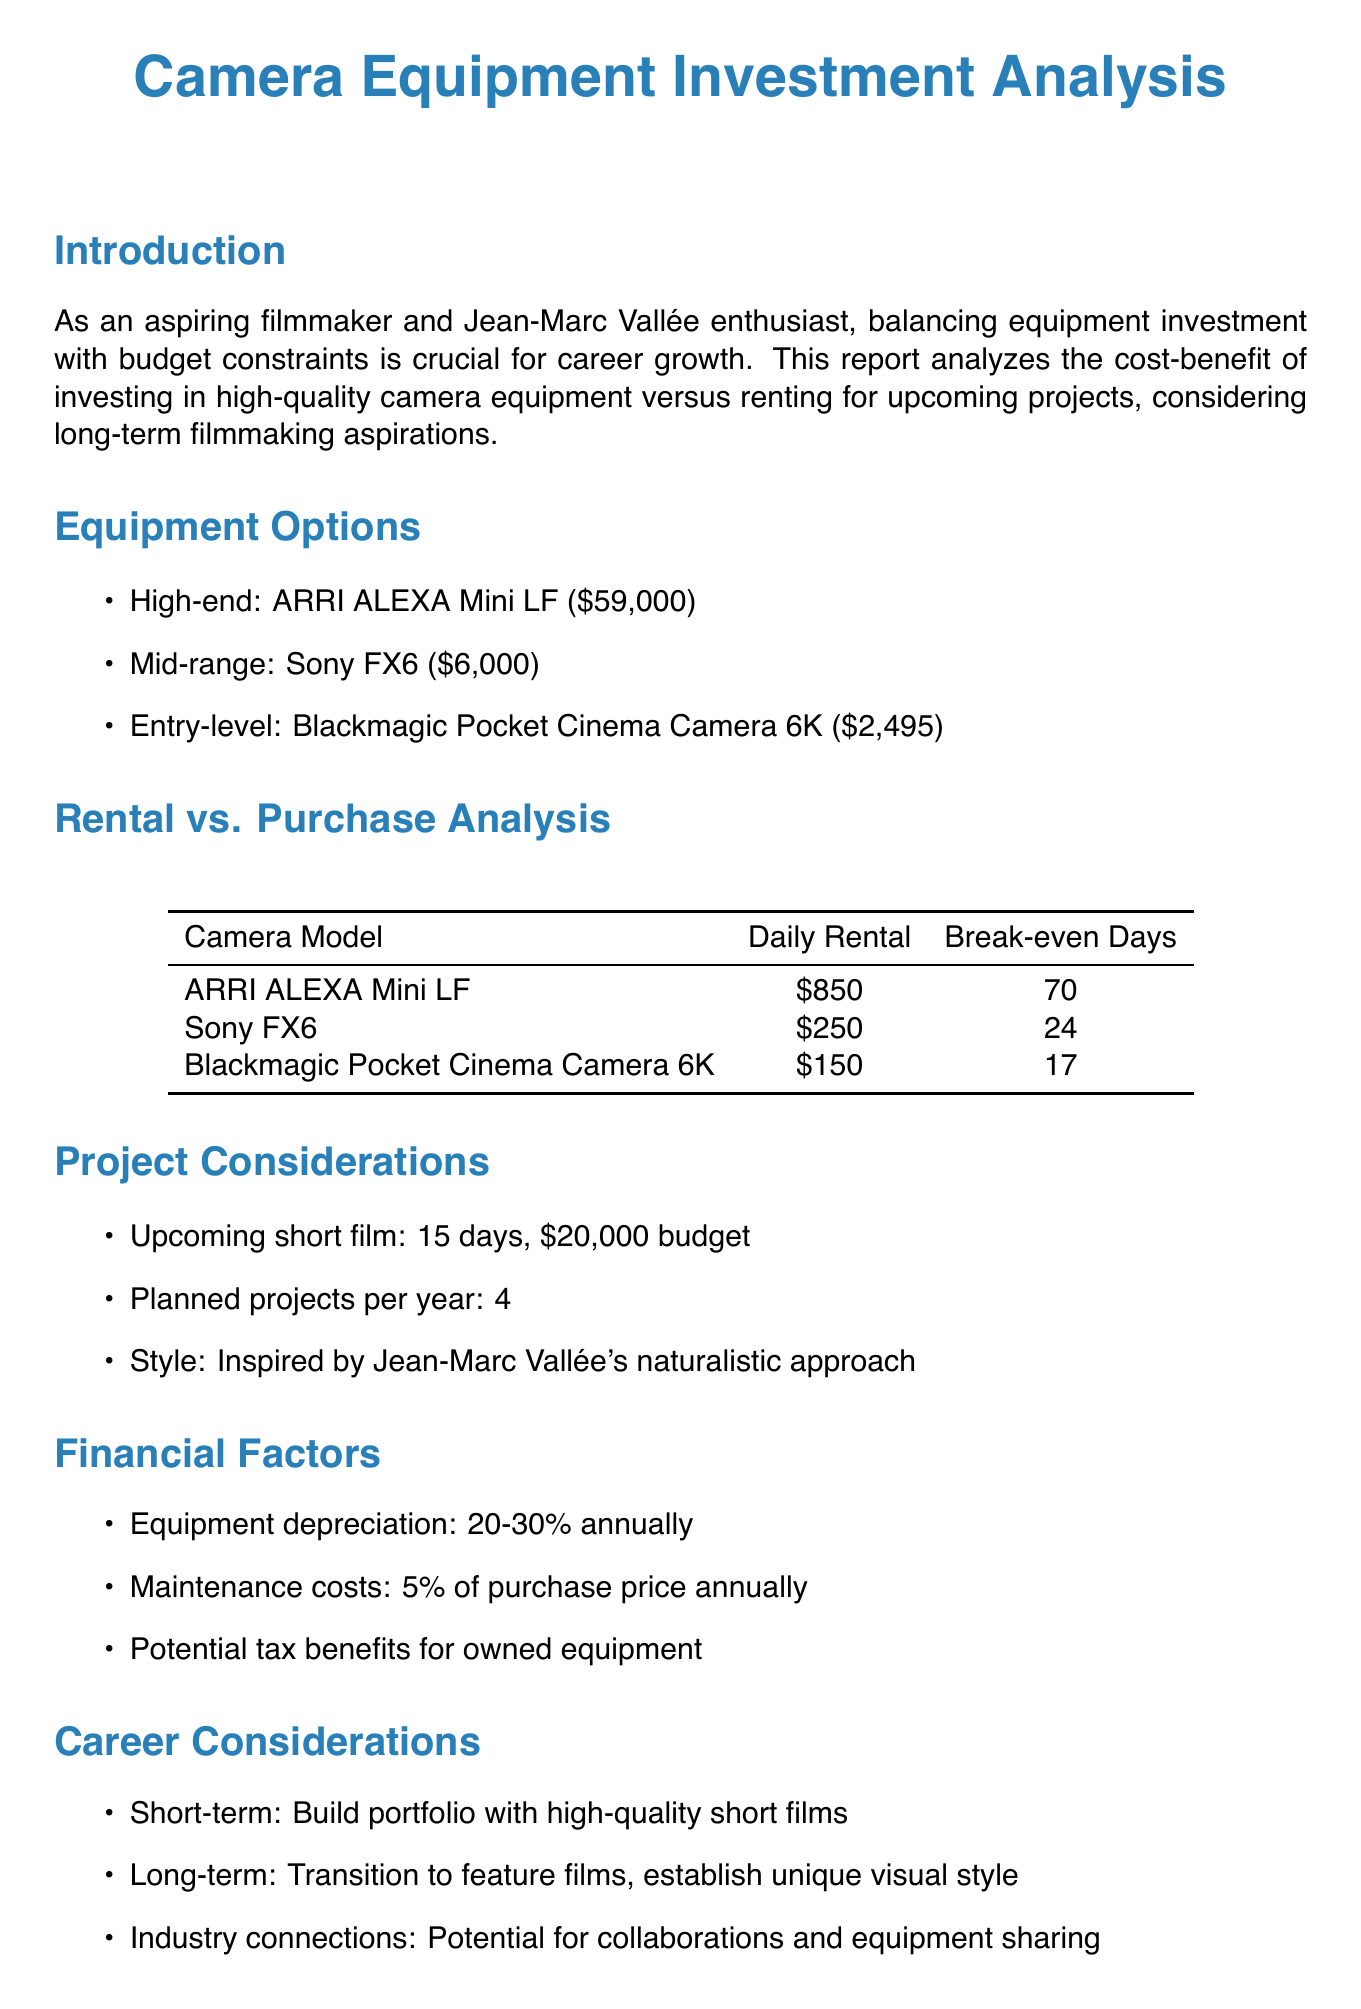What is the high-end camera mentioned? The document lists the ARRI ALEXA Mini LF as the high-end camera option.
Answer: ARRI ALEXA Mini LF What is the purchase cost of the Sony FX6? The document states that the purchase cost of the Sony FX6 is $6,000.
Answer: $6,000 What is the daily rental cost of the Blackmagic Pocket Cinema Camera 6K? According to the document, the daily rental cost for the Blackmagic Pocket Cinema Camera 6K is $150.
Answer: $150 How many planned projects are there per year? The document mentions that there are 4 planned projects per year.
Answer: 4 What is the recommended camera for purchase? The document recommends purchasing the Sony FX6 for its balance of quality and affordability.
Answer: Sony FX6 What is the depreciation rate for camera equipment? The document specifies that camera equipment typically depreciates 20-30% annually.
Answer: 20-30% What is the upcoming short film's duration? The duration of the upcoming short film mentioned in the document is 15 days.
Answer: 15 days What are the potential tax benefits mentioned? The document notes that there are potential tax deductions for owned equipment.
Answer: Tax deductions What is the style of the upcoming short film? The document states that the style of the upcoming short film is inspired by Jean-Marc Vallée's naturalistic approach.
Answer: Naturalistic approach 